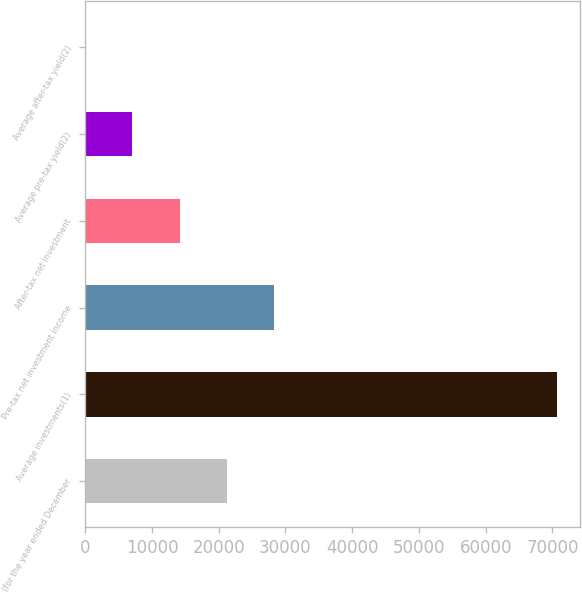<chart> <loc_0><loc_0><loc_500><loc_500><bar_chart><fcel>(for the year ended December<fcel>Average investments(1)<fcel>Pre-tax net investment income<fcel>After-tax net investment<fcel>Average pre-tax yield(2)<fcel>Average after-tax yield(2)<nl><fcel>21190<fcel>70627<fcel>28252.4<fcel>14127.6<fcel>7065.13<fcel>2.7<nl></chart> 